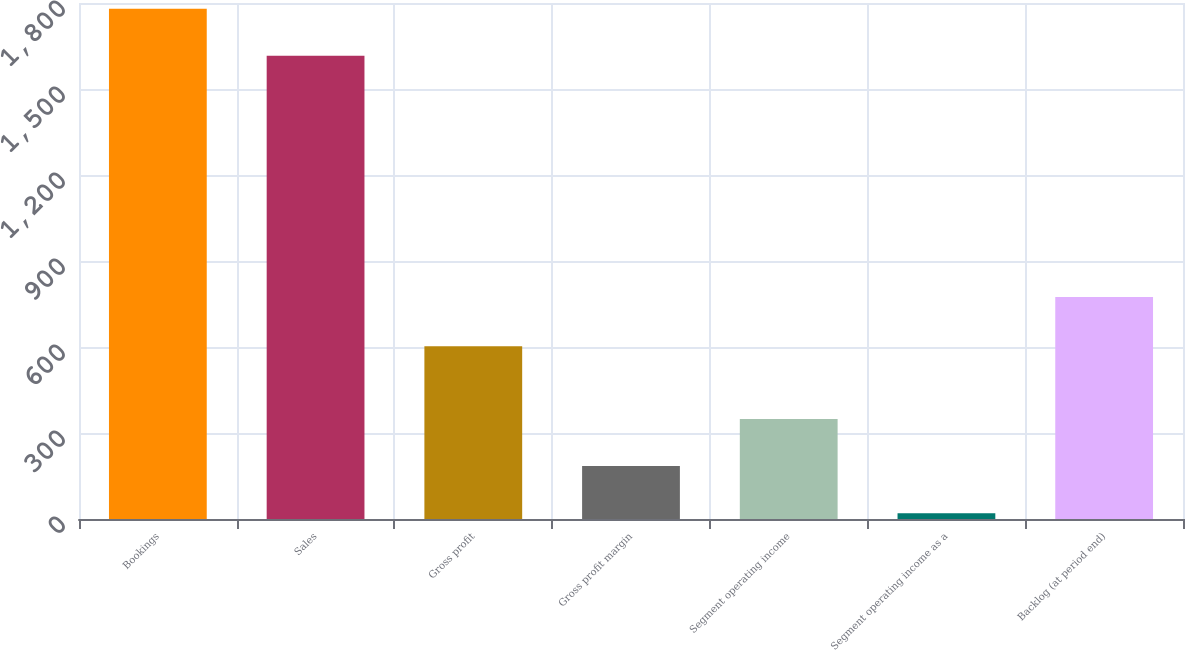Convert chart. <chart><loc_0><loc_0><loc_500><loc_500><bar_chart><fcel>Bookings<fcel>Sales<fcel>Gross profit<fcel>Gross profit margin<fcel>Segment operating income<fcel>Segment operating income as a<fcel>Backlog (at period end)<nl><fcel>1780.22<fcel>1615.7<fcel>603<fcel>184.52<fcel>349.04<fcel>20<fcel>774.8<nl></chart> 